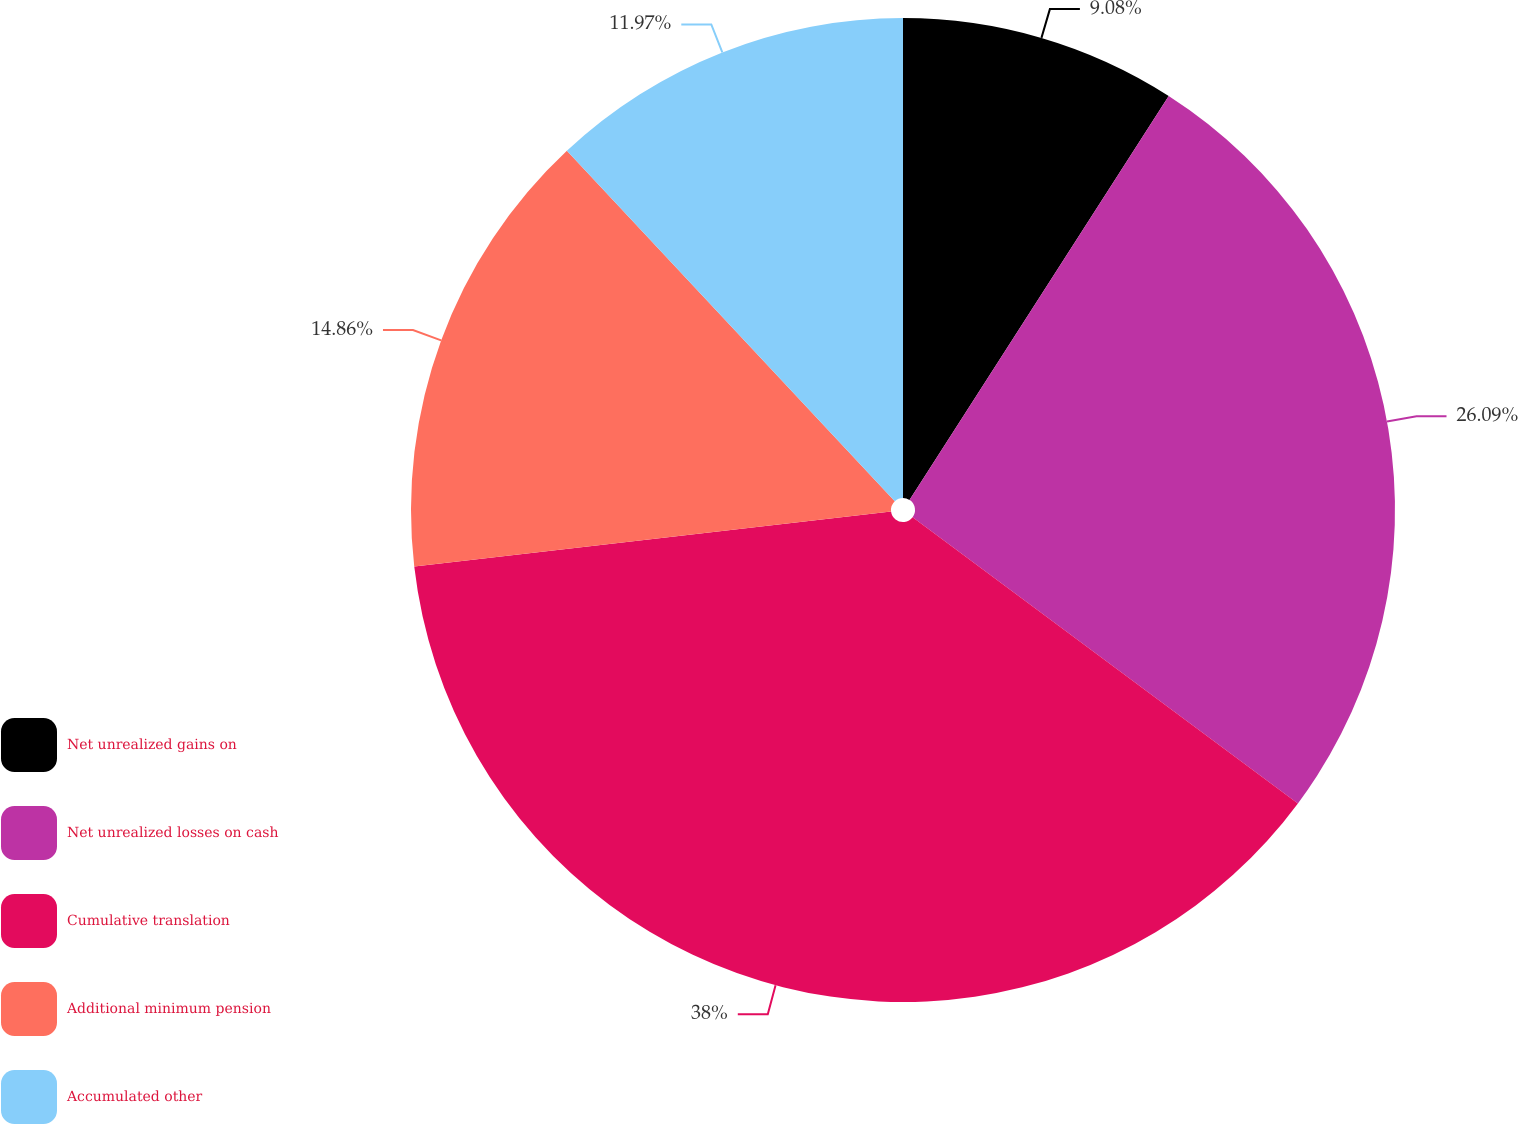<chart> <loc_0><loc_0><loc_500><loc_500><pie_chart><fcel>Net unrealized gains on<fcel>Net unrealized losses on cash<fcel>Cumulative translation<fcel>Additional minimum pension<fcel>Accumulated other<nl><fcel>9.08%<fcel>26.09%<fcel>38.0%<fcel>14.86%<fcel>11.97%<nl></chart> 